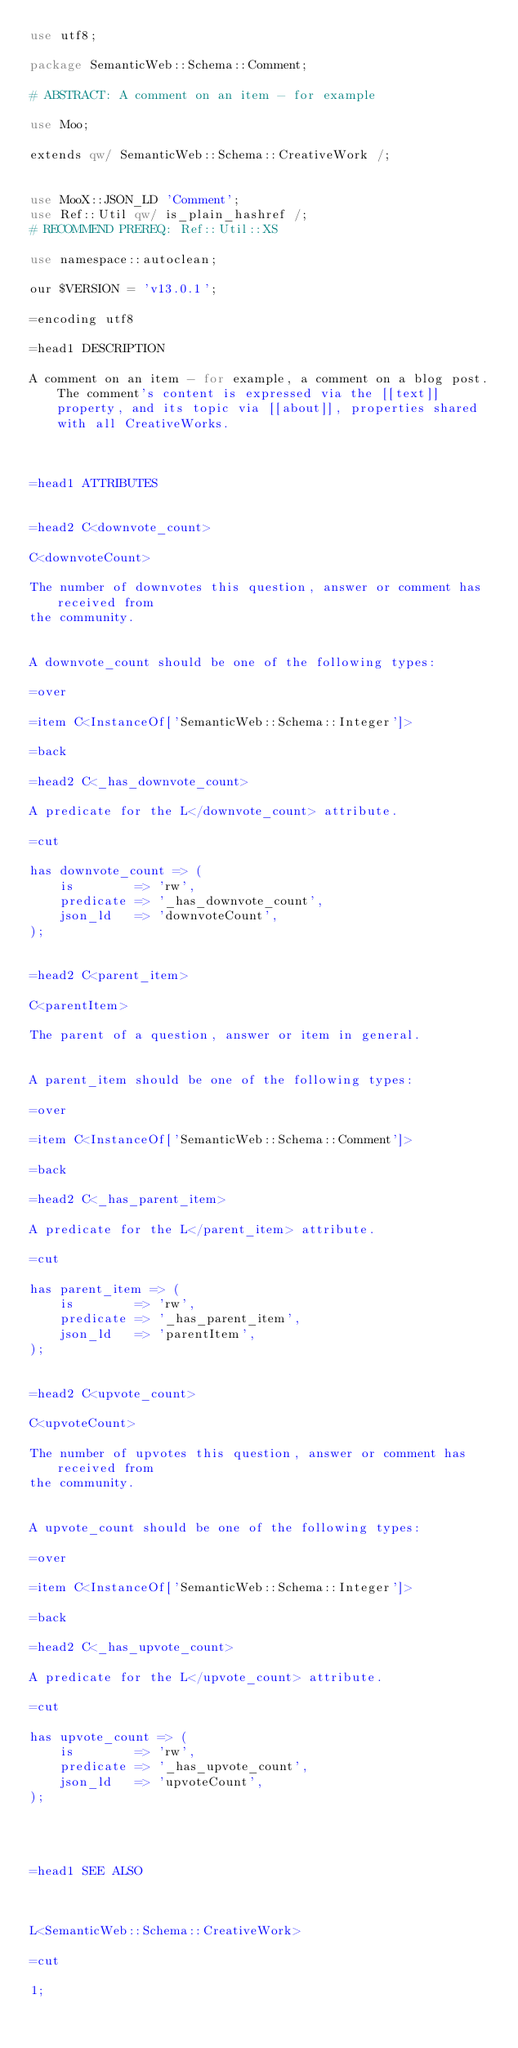Convert code to text. <code><loc_0><loc_0><loc_500><loc_500><_Perl_>use utf8;

package SemanticWeb::Schema::Comment;

# ABSTRACT: A comment on an item - for example

use Moo;

extends qw/ SemanticWeb::Schema::CreativeWork /;


use MooX::JSON_LD 'Comment';
use Ref::Util qw/ is_plain_hashref /;
# RECOMMEND PREREQ: Ref::Util::XS

use namespace::autoclean;

our $VERSION = 'v13.0.1';

=encoding utf8

=head1 DESCRIPTION

A comment on an item - for example, a comment on a blog post. The comment's content is expressed via the [[text]] property, and its topic via [[about]], properties shared with all CreativeWorks.



=head1 ATTRIBUTES


=head2 C<downvote_count>

C<downvoteCount>

The number of downvotes this question, answer or comment has received from
the community.


A downvote_count should be one of the following types:

=over

=item C<InstanceOf['SemanticWeb::Schema::Integer']>

=back

=head2 C<_has_downvote_count>

A predicate for the L</downvote_count> attribute.

=cut

has downvote_count => (
    is        => 'rw',
    predicate => '_has_downvote_count',
    json_ld   => 'downvoteCount',
);


=head2 C<parent_item>

C<parentItem>

The parent of a question, answer or item in general.


A parent_item should be one of the following types:

=over

=item C<InstanceOf['SemanticWeb::Schema::Comment']>

=back

=head2 C<_has_parent_item>

A predicate for the L</parent_item> attribute.

=cut

has parent_item => (
    is        => 'rw',
    predicate => '_has_parent_item',
    json_ld   => 'parentItem',
);


=head2 C<upvote_count>

C<upvoteCount>

The number of upvotes this question, answer or comment has received from
the community.


A upvote_count should be one of the following types:

=over

=item C<InstanceOf['SemanticWeb::Schema::Integer']>

=back

=head2 C<_has_upvote_count>

A predicate for the L</upvote_count> attribute.

=cut

has upvote_count => (
    is        => 'rw',
    predicate => '_has_upvote_count',
    json_ld   => 'upvoteCount',
);




=head1 SEE ALSO



L<SemanticWeb::Schema::CreativeWork>

=cut

1;
</code> 